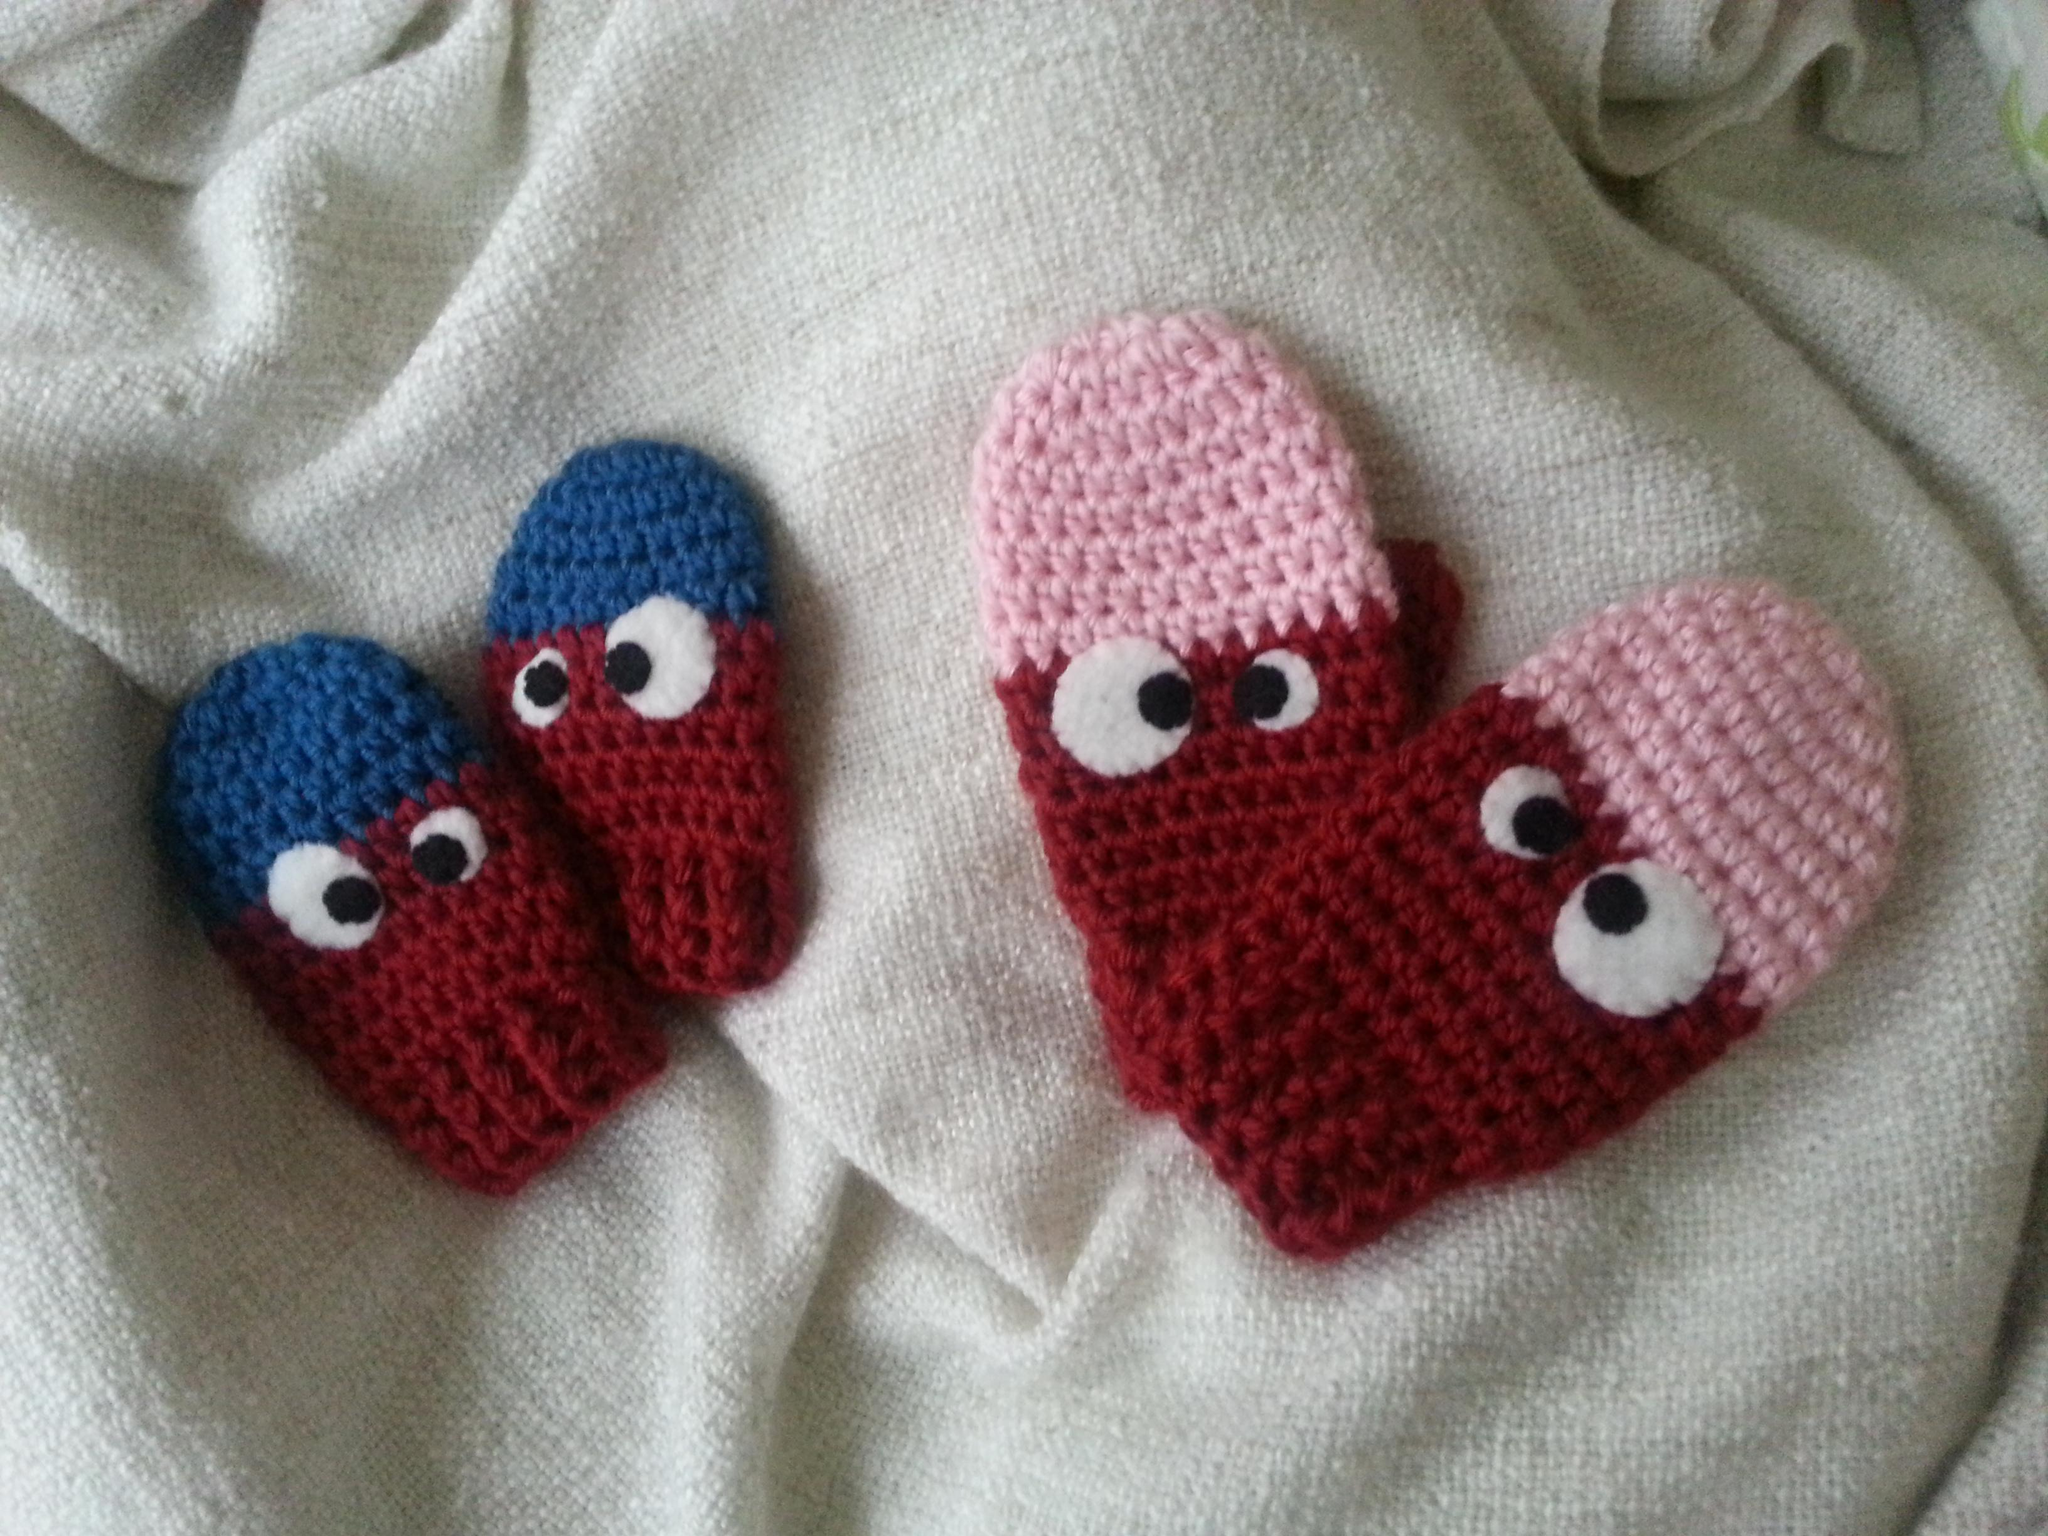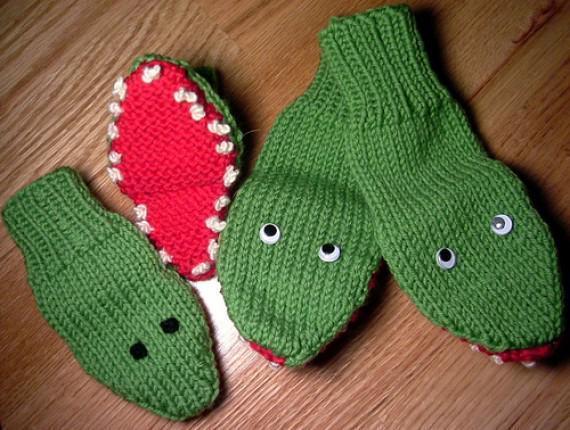The first image is the image on the left, the second image is the image on the right. For the images shown, is this caption "there are at least two pairs of mittens in the image on the left" true? Answer yes or no. Yes. The first image is the image on the left, the second image is the image on the right. Considering the images on both sides, is "One image shows a single pair of blue gloves that are not furry." valid? Answer yes or no. No. 